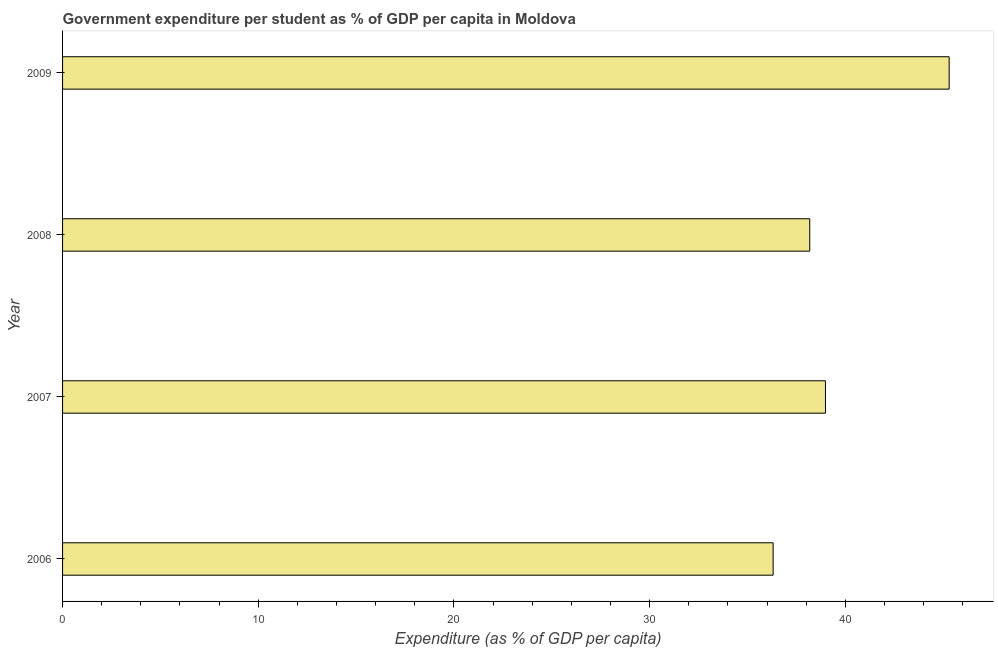Does the graph contain any zero values?
Ensure brevity in your answer.  No. What is the title of the graph?
Your answer should be compact. Government expenditure per student as % of GDP per capita in Moldova. What is the label or title of the X-axis?
Give a very brief answer. Expenditure (as % of GDP per capita). What is the label or title of the Y-axis?
Your answer should be very brief. Year. What is the government expenditure per student in 2006?
Give a very brief answer. 36.31. Across all years, what is the maximum government expenditure per student?
Make the answer very short. 45.31. Across all years, what is the minimum government expenditure per student?
Your answer should be very brief. 36.31. What is the sum of the government expenditure per student?
Provide a short and direct response. 158.79. What is the difference between the government expenditure per student in 2007 and 2009?
Your answer should be very brief. -6.32. What is the average government expenditure per student per year?
Make the answer very short. 39.7. What is the median government expenditure per student?
Offer a very short reply. 38.59. In how many years, is the government expenditure per student greater than 38 %?
Your response must be concise. 3. What is the ratio of the government expenditure per student in 2008 to that in 2009?
Provide a succinct answer. 0.84. Is the government expenditure per student in 2007 less than that in 2009?
Provide a short and direct response. Yes. Is the difference between the government expenditure per student in 2006 and 2007 greater than the difference between any two years?
Provide a succinct answer. No. What is the difference between the highest and the second highest government expenditure per student?
Your answer should be very brief. 6.32. Is the sum of the government expenditure per student in 2008 and 2009 greater than the maximum government expenditure per student across all years?
Your response must be concise. Yes. What is the difference between the highest and the lowest government expenditure per student?
Make the answer very short. 9. How many bars are there?
Your response must be concise. 4. What is the difference between two consecutive major ticks on the X-axis?
Your answer should be compact. 10. What is the Expenditure (as % of GDP per capita) in 2006?
Give a very brief answer. 36.31. What is the Expenditure (as % of GDP per capita) in 2007?
Your answer should be very brief. 38.99. What is the Expenditure (as % of GDP per capita) of 2008?
Provide a short and direct response. 38.18. What is the Expenditure (as % of GDP per capita) of 2009?
Make the answer very short. 45.31. What is the difference between the Expenditure (as % of GDP per capita) in 2006 and 2007?
Make the answer very short. -2.68. What is the difference between the Expenditure (as % of GDP per capita) in 2006 and 2008?
Make the answer very short. -1.87. What is the difference between the Expenditure (as % of GDP per capita) in 2006 and 2009?
Provide a succinct answer. -9. What is the difference between the Expenditure (as % of GDP per capita) in 2007 and 2008?
Your response must be concise. 0.8. What is the difference between the Expenditure (as % of GDP per capita) in 2007 and 2009?
Ensure brevity in your answer.  -6.32. What is the difference between the Expenditure (as % of GDP per capita) in 2008 and 2009?
Make the answer very short. -7.12. What is the ratio of the Expenditure (as % of GDP per capita) in 2006 to that in 2008?
Give a very brief answer. 0.95. What is the ratio of the Expenditure (as % of GDP per capita) in 2006 to that in 2009?
Offer a terse response. 0.8. What is the ratio of the Expenditure (as % of GDP per capita) in 2007 to that in 2009?
Your answer should be compact. 0.86. What is the ratio of the Expenditure (as % of GDP per capita) in 2008 to that in 2009?
Offer a very short reply. 0.84. 